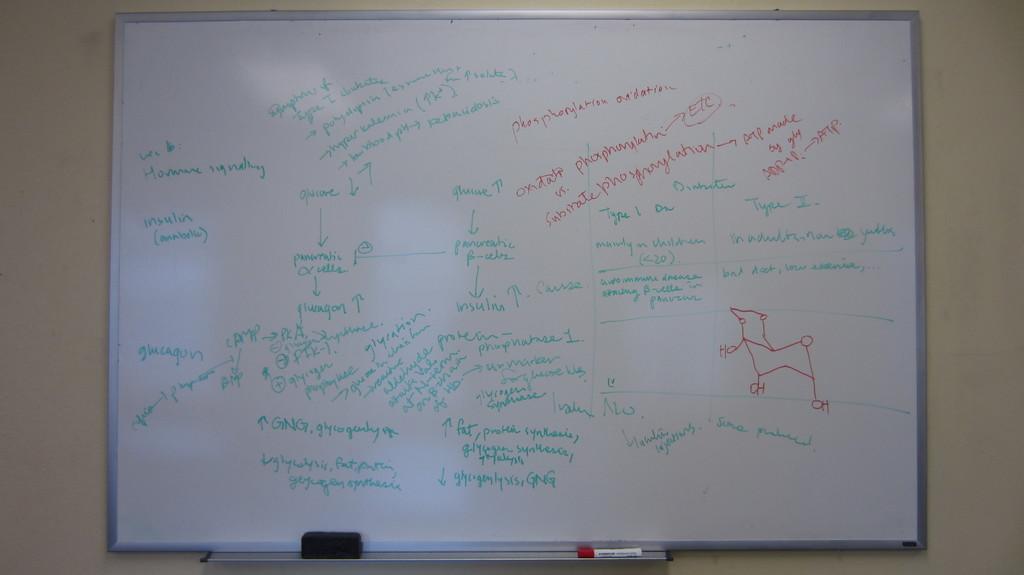Is the word insulin on the board?
Offer a terse response. Yes. 